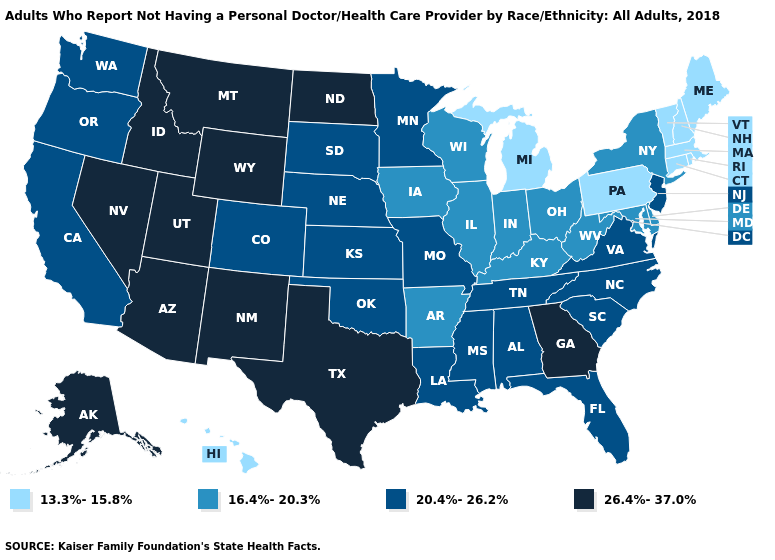Which states have the lowest value in the MidWest?
Answer briefly. Michigan. Name the states that have a value in the range 13.3%-15.8%?
Be succinct. Connecticut, Hawaii, Maine, Massachusetts, Michigan, New Hampshire, Pennsylvania, Rhode Island, Vermont. Name the states that have a value in the range 16.4%-20.3%?
Write a very short answer. Arkansas, Delaware, Illinois, Indiana, Iowa, Kentucky, Maryland, New York, Ohio, West Virginia, Wisconsin. Which states have the lowest value in the South?
Answer briefly. Arkansas, Delaware, Kentucky, Maryland, West Virginia. Which states have the lowest value in the USA?
Short answer required. Connecticut, Hawaii, Maine, Massachusetts, Michigan, New Hampshire, Pennsylvania, Rhode Island, Vermont. Is the legend a continuous bar?
Quick response, please. No. Name the states that have a value in the range 26.4%-37.0%?
Be succinct. Alaska, Arizona, Georgia, Idaho, Montana, Nevada, New Mexico, North Dakota, Texas, Utah, Wyoming. Does the first symbol in the legend represent the smallest category?
Write a very short answer. Yes. Which states have the highest value in the USA?
Be succinct. Alaska, Arizona, Georgia, Idaho, Montana, Nevada, New Mexico, North Dakota, Texas, Utah, Wyoming. Name the states that have a value in the range 16.4%-20.3%?
Be succinct. Arkansas, Delaware, Illinois, Indiana, Iowa, Kentucky, Maryland, New York, Ohio, West Virginia, Wisconsin. What is the value of Michigan?
Give a very brief answer. 13.3%-15.8%. Does Delaware have the same value as Tennessee?
Give a very brief answer. No. Does Vermont have the lowest value in the USA?
Be succinct. Yes. What is the value of Nevada?
Give a very brief answer. 26.4%-37.0%. What is the value of Colorado?
Short answer required. 20.4%-26.2%. 